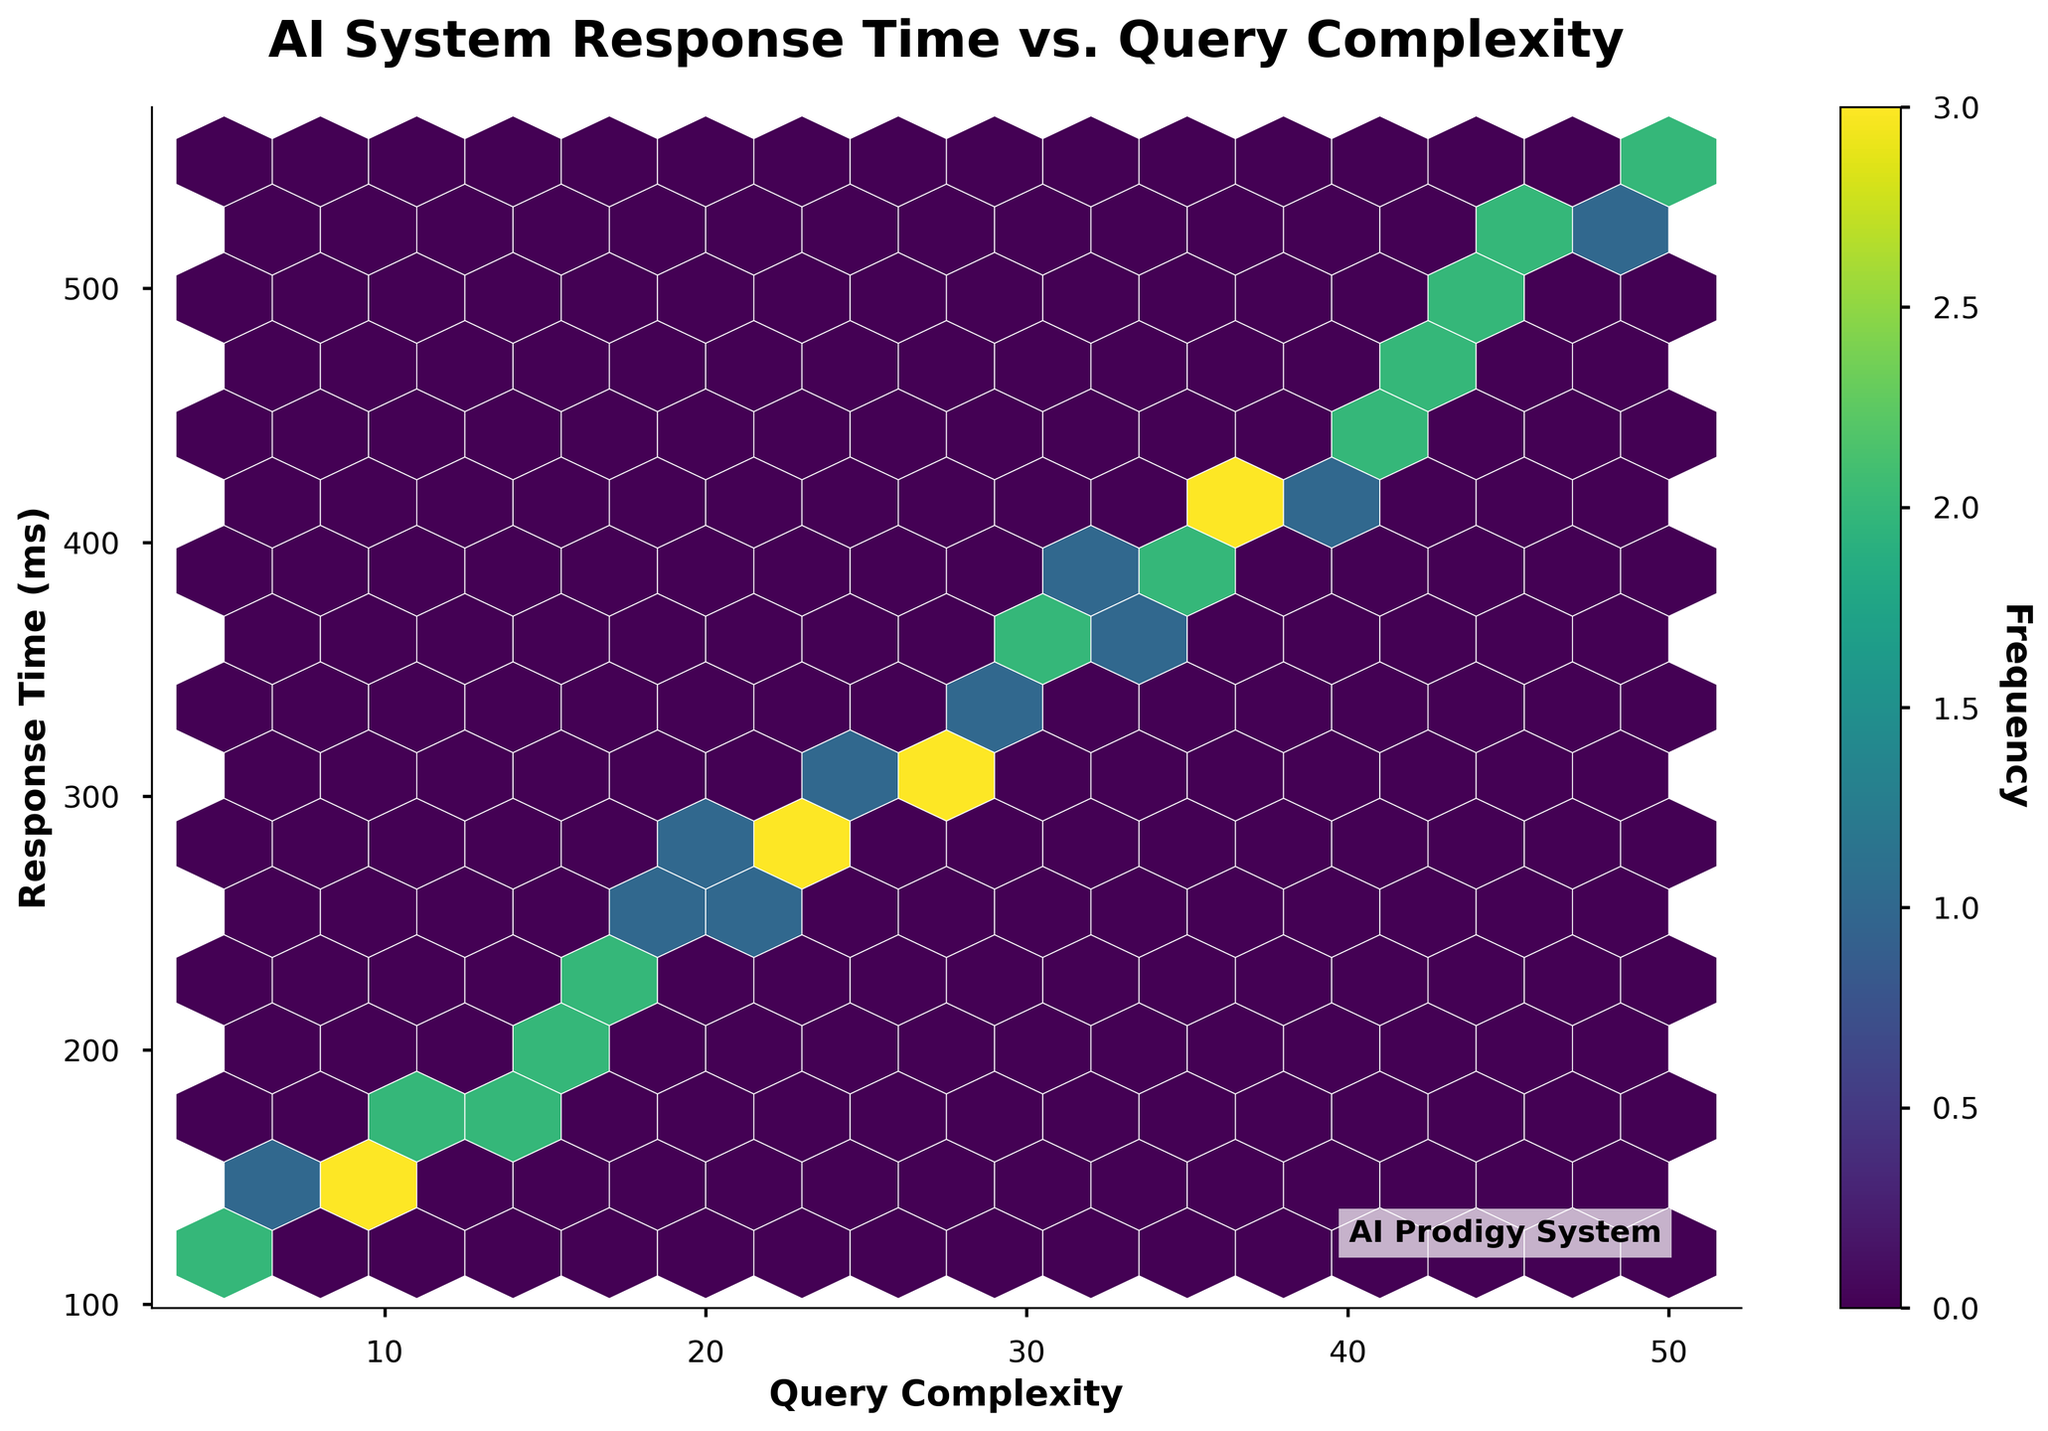What is the title of the hexbin plot? The title of the hexbin plot is prominently displayed at the top of the figure.
Answer: AI System Response Time vs. Query Complexity What is the color gradient in the hexbin plot representing? The color gradient in the hexbin plot represents the frequency of data points. Darker colors indicate higher frequencies.
Answer: Frequency of data points What does the x-axis label indicate? The x-axis label, located at the bottom of the plot, indicates the aspect of the data represented along the horizontal axis.
Answer: Query Complexity What does the y-axis label indicate? The y-axis label, located at the left of the plot, indicates the aspect of the data represented along the vertical axis.
Answer: Response Time (ms) What is the range of Query Complexity? The range can be determined by looking at the lowest and highest values along the x-axis labeled ticks.
Answer: 5 to 50 What is the range of Response Time (ms)? The range can be determined by looking at the lowest and highest values along the y-axis labeled ticks.
Answer: 120 to 550 At what Query Complexity value do you observe the highest frequency of data points? The highest frequency is indicated by the darkest color in the hexbin plot. Locate that hexbin and see its corresponding x-axis value.
Answer: Around 30 What does the color bar on the right side of the plot indicate? The color bar provides a scale for interpreting the frequency of data points, with different colors representing different frequencies.
Answer: Frequency of data points How does Response Time tend to change as Query Complexity increases? By observing the trend in the plot, it can be noticed that the Response Time increases as the Query Complexity increases.
Answer: Increases Between Query Complexities of 10 and 20, is the Response Time more likely to be over 200 ms or under 200 ms? Look at the hexbin regions between 10 and 20 Query Complexity and check the colors above and below 200 ms.
Answer: Over 200 ms Is there any Query Complexity with a Response Time above 500 ms? Identify hexbin regions with Response Times above 500 ms and note their Query Complexity values.
Answer: Yes, above 45 